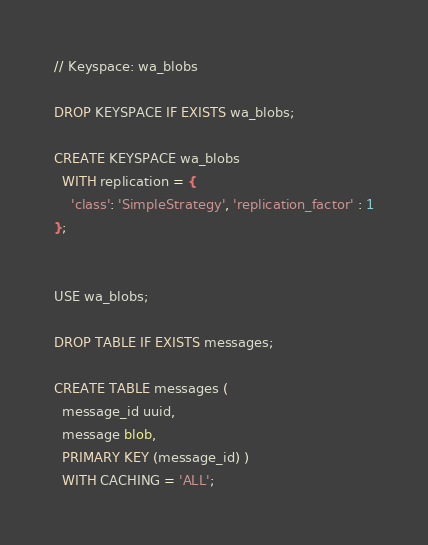Convert code to text. <code><loc_0><loc_0><loc_500><loc_500><_SQL_>// Keyspace: wa_blobs

DROP KEYSPACE IF EXISTS wa_blobs;

CREATE KEYSPACE wa_blobs
  WITH replication = {
    'class': 'SimpleStrategy', 'replication_factor' : 1
};


USE wa_blobs;

DROP TABLE IF EXISTS messages;

CREATE TABLE messages (
  message_id uuid,
  message blob,
  PRIMARY KEY (message_id) )
  WITH CACHING = 'ALL';


</code> 